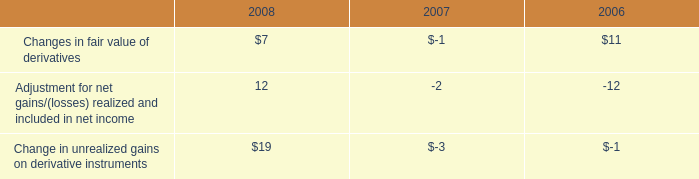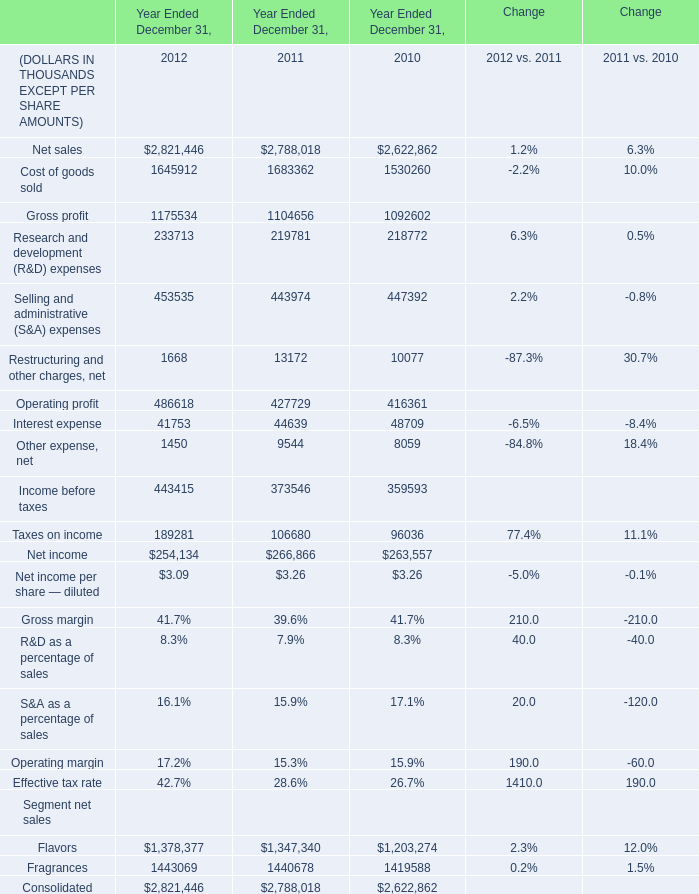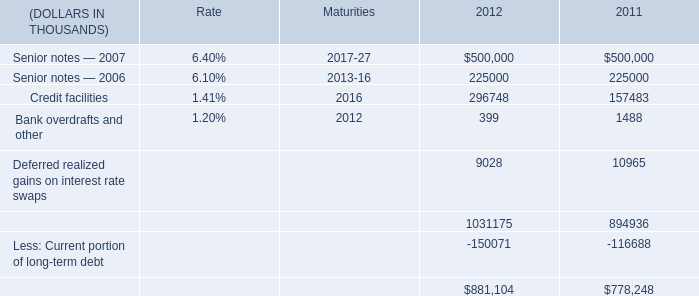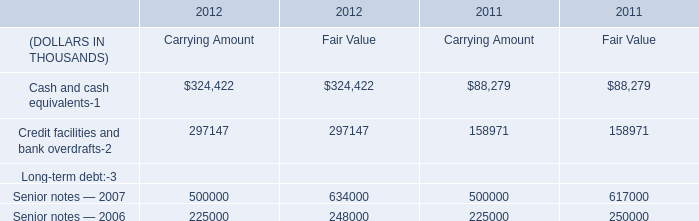What is the total amount of Net sales of Year Ended December 31, 2012, and Senior notes — 2007 of 2011 ? 
Computations: (2821446.0 + 500000.0)
Answer: 3321446.0. 